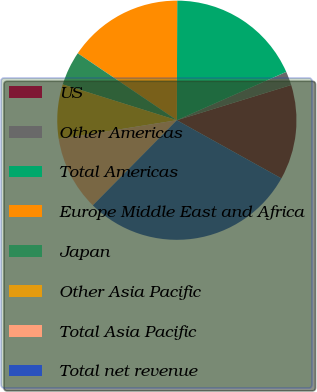Convert chart to OTSL. <chart><loc_0><loc_0><loc_500><loc_500><pie_chart><fcel>US<fcel>Other Americas<fcel>Total Americas<fcel>Europe Middle East and Africa<fcel>Japan<fcel>Other Asia Pacific<fcel>Total Asia Pacific<fcel>Total net revenue<nl><fcel>12.84%<fcel>1.87%<fcel>18.33%<fcel>15.59%<fcel>4.61%<fcel>7.35%<fcel>10.1%<fcel>29.31%<nl></chart> 